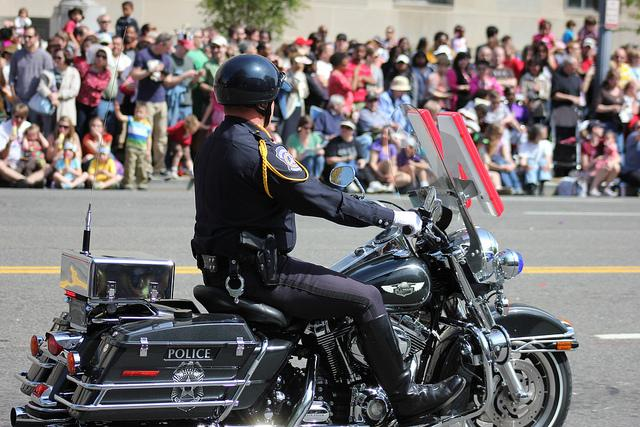What are the people on the street side focused on? Please explain your reasoning. parade. The people are lined up on the street to watch something. 